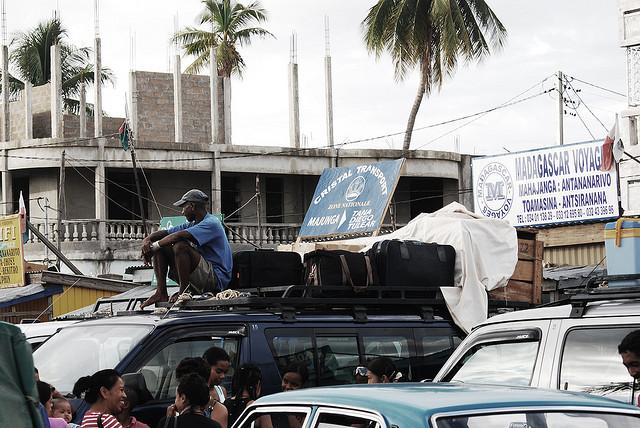These people are on what continent? africa 